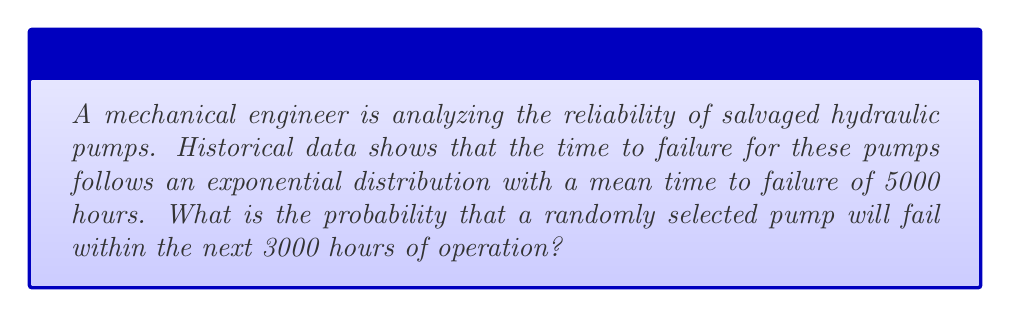Teach me how to tackle this problem. To solve this problem, we'll use the exponential distribution, which is commonly used to model the time between events in a Poisson point process.

1. The probability density function for the exponential distribution is:
   $$f(t) = λe^{-λt}$$
   where λ is the rate parameter.

2. The mean time to failure (MTTF) is given as 5000 hours. For the exponential distribution:
   $$MTTF = \frac{1}{λ}$$

3. Therefore:
   $$5000 = \frac{1}{λ}$$
   $$λ = \frac{1}{5000} = 0.0002$$

4. The probability of failure within time t is given by the cumulative distribution function:
   $$P(T ≤ t) = 1 - e^{-λt}$$

5. Substituting our values:
   $$P(T ≤ 3000) = 1 - e^{-0.0002 * 3000}$$

6. Calculating:
   $$P(T ≤ 3000) = 1 - e^{-0.6}$$
   $$P(T ≤ 3000) = 1 - 0.5488$$
   $$P(T ≤ 3000) = 0.4512$$

Therefore, the probability that a randomly selected pump will fail within the next 3000 hours of operation is approximately 0.4512 or 45.12%.
Answer: 0.4512 